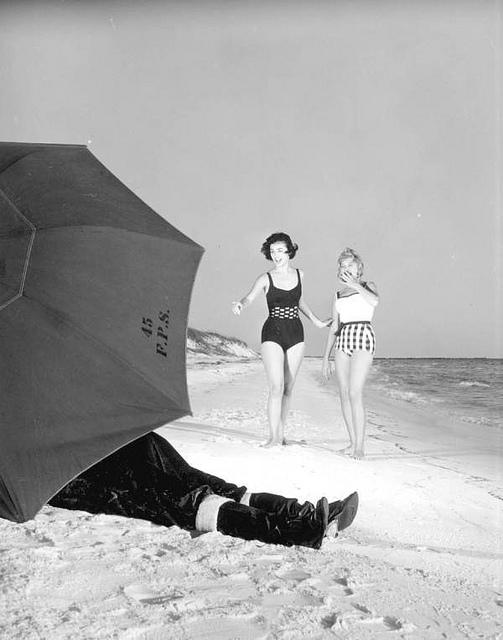Why are the girls standing?
Short answer required. Walking. Are the girls on the beach?
Keep it brief. Yes. Are the women in one piece bikini's?
Keep it brief. Yes. 